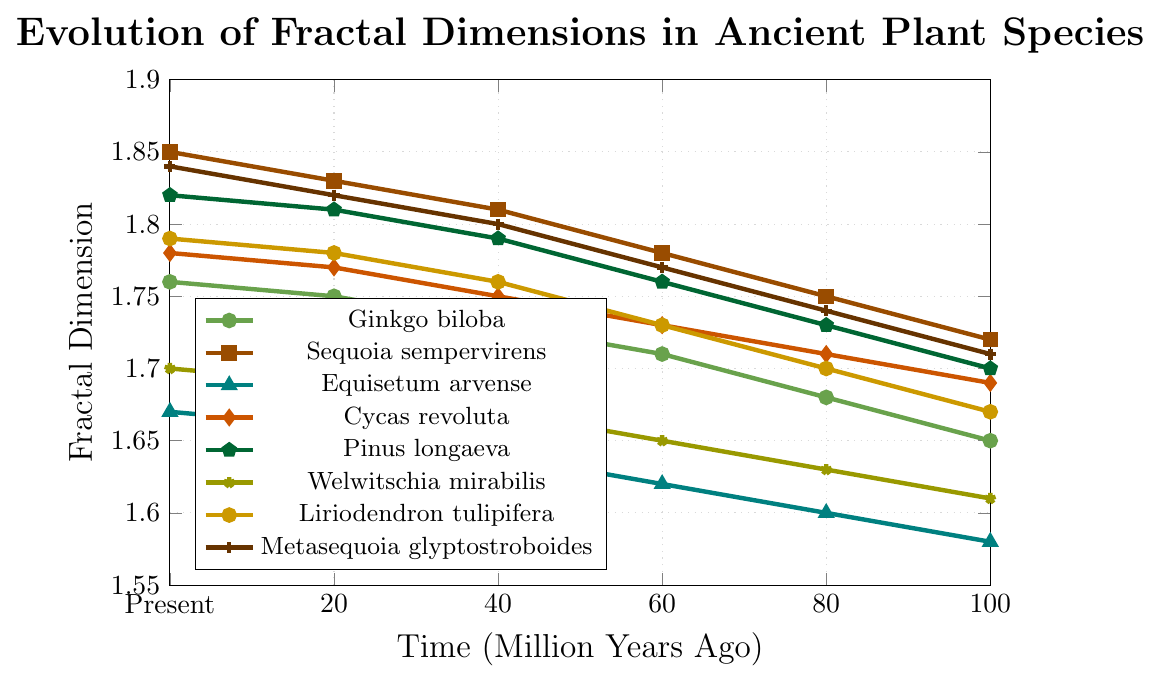Which plant species shows the highest fractal dimension in the present time? The present time fractal dimensions are plotted on the y-axis at the 0 MYA mark on the x-axis. The highest value among the present time dimensions is 1.85, corresponding to Sequoia sempervirens.
Answer: Sequoia sempervirens Which plant species has the smallest change in fractal dimension over 100 million years? Calculate the change by subtracting the fractal dimension values at 100 MYA from those at the present time. The smallest change is 0.09 for Equisetum arvense, from 1.58 to 1.67.
Answer: Equisetum arvense Among Ginkgo biloba and Welwitschia mirabilis, which species has a higher fractal dimension at 40 MYA? Locate 40 MYA on the x-axis and compare the y-values of Ginkgo biloba (1.73) and Welwitschia mirabilis (1.67).
Answer: Ginkgo biloba How many species have a fractal dimension greater than 1.80 in the present time? Check the y-values at 0 MYA and count the species with fractal dimensions above 1.80: Sequoia sempervirens (1.85), Pinus longaeva (1.82), and Metasequoia glyptostroboides (1.84). Three species meet this criterion.
Answer: 3 What is the difference in fractal dimension between Cycas revoluta and Liriodendron tulipifera at 80 MYA? At 80 MYA, Cycas revoluta has a fractal dimension of 1.71 and Liriodendron tulipifera has 1.70. The difference is 1.71 - 1.70 = 0.01.
Answer: 0.01 Which species' fractal dimension increased the most from 60 MYA to 40 MYA? Compare the differences in the y-values between 60 MYA and 40 MYA for all species: Ginkgo biloba (0.02), Sequoia sempervirens (0.03), Equisetum arvense (0.02), Cycas revoluta (0.02), Pinus longaeva (0.03), Welwitschia mirabilis (0.02), Liriodendron tulipifera (0.03), Metasequoia glyptostroboides (0.03). The maximum increase of 0.03 is shared by Sequoia sempervirens, Pinus longaeva, Liriodendron tulipifera, and Metasequoia glyptostroboides.
Answer: Sequoia sempervirens, Pinus longaeva, Liriodendron tulipifera, Metasequoia glyptostroboides What is the average fractal dimension of Metasequoia glyptostroboides over time? Sum the fractal dimensions for Metasequoia glyptostroboides at 100 MYA, 80 MYA, 60 MYA, 40 MYA, 20 MYA, and Present, then divide by 6: (1.71 + 1.74 + 1.77 + 1.80 + 1.82 + 1.84) / 6 = 10.68 / 6 = 1.78.
Answer: 1.78 